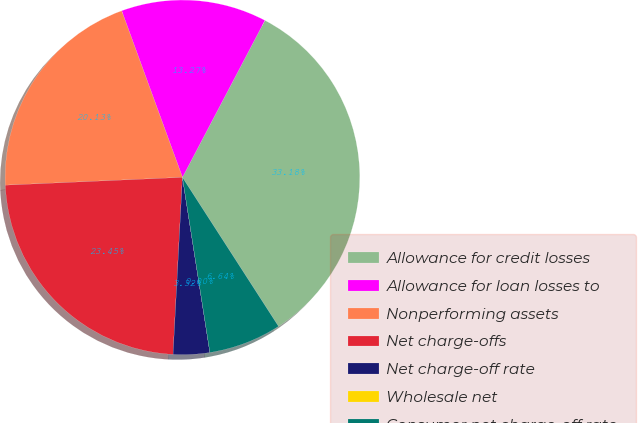<chart> <loc_0><loc_0><loc_500><loc_500><pie_chart><fcel>Allowance for credit losses<fcel>Allowance for loan losses to<fcel>Nonperforming assets<fcel>Net charge-offs<fcel>Net charge-off rate<fcel>Wholesale net<fcel>Consumer net charge-off rate<nl><fcel>33.18%<fcel>13.27%<fcel>20.13%<fcel>23.45%<fcel>3.32%<fcel>0.0%<fcel>6.64%<nl></chart> 